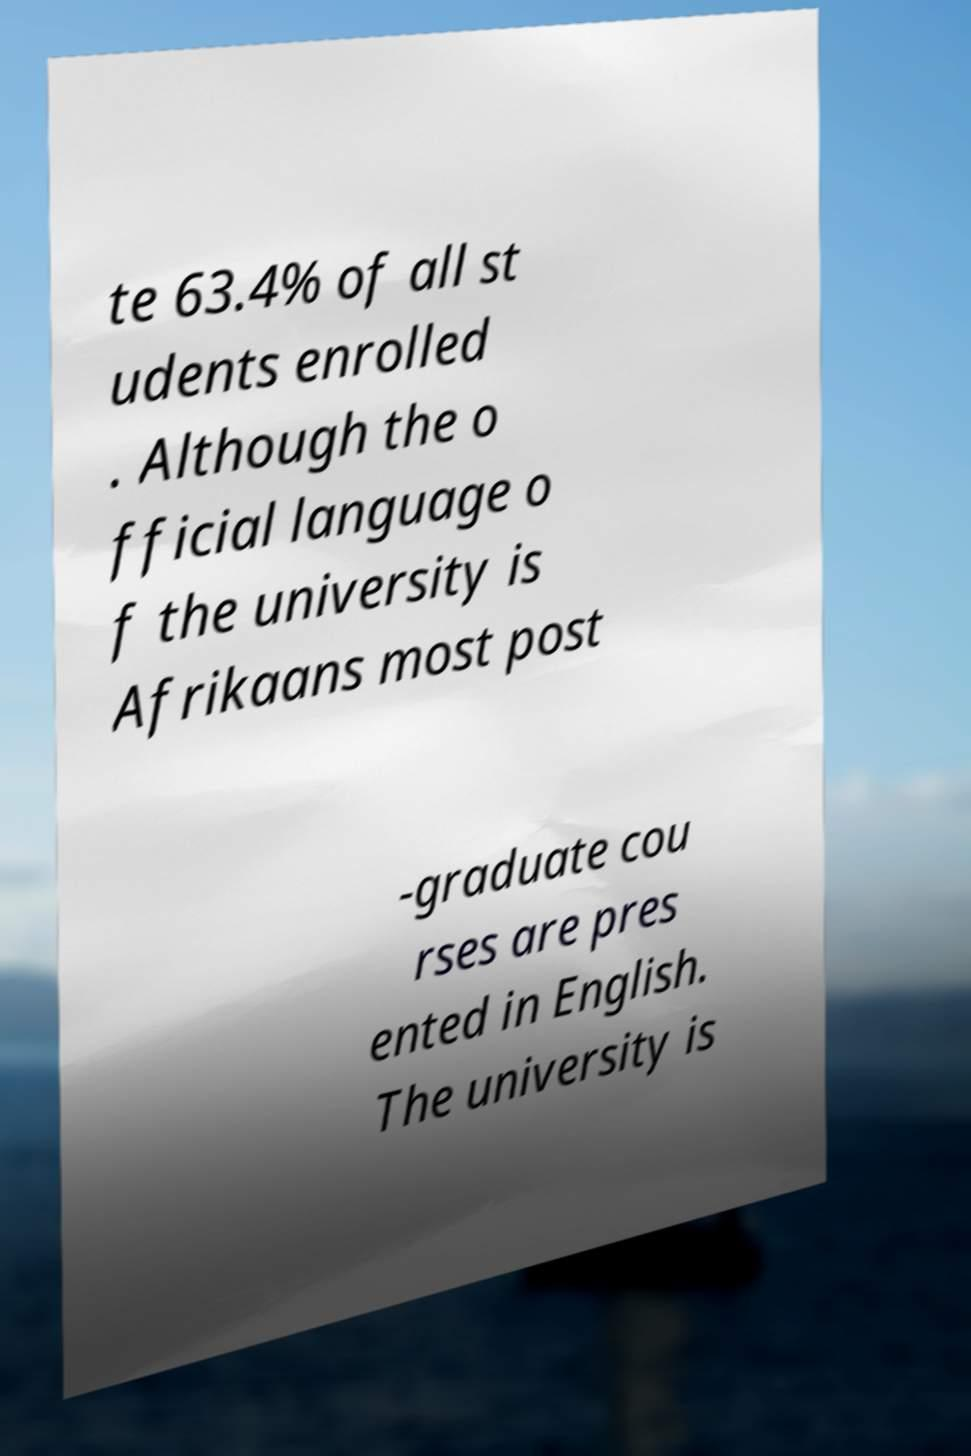For documentation purposes, I need the text within this image transcribed. Could you provide that? te 63.4% of all st udents enrolled . Although the o fficial language o f the university is Afrikaans most post -graduate cou rses are pres ented in English. The university is 